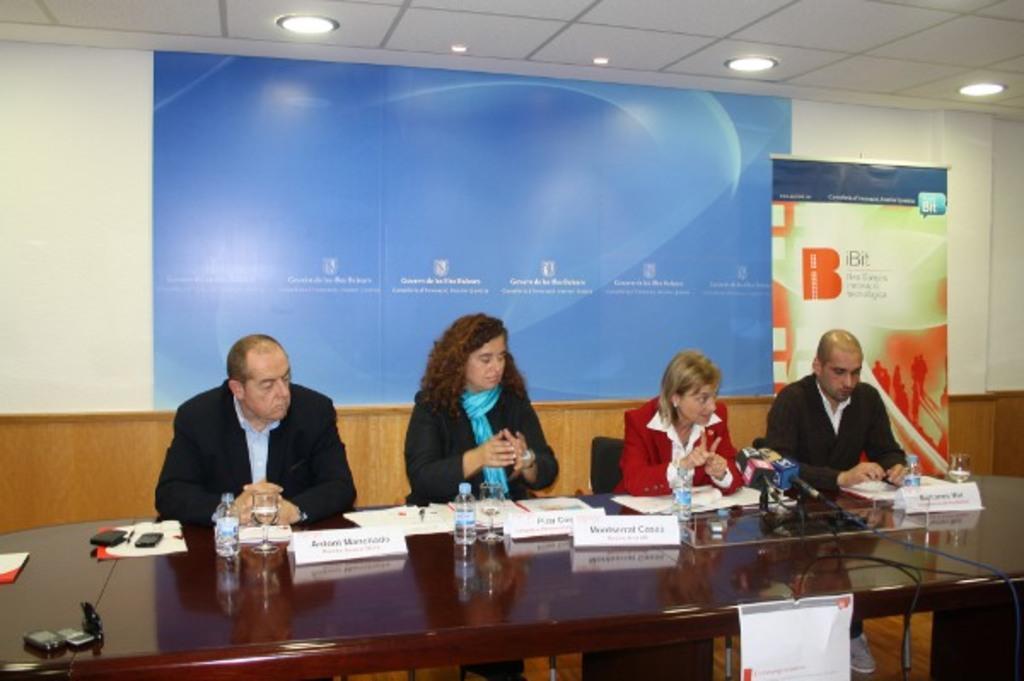Could you give a brief overview of what you see in this image? This image consists of four persons sitting in the chairs. In front of them, there is a table on which there are bottles, and name boards along with papers are kept. In the background, there is a screen and a banner. At the top, there are lights. 